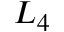<formula> <loc_0><loc_0><loc_500><loc_500>L _ { 4 }</formula> 